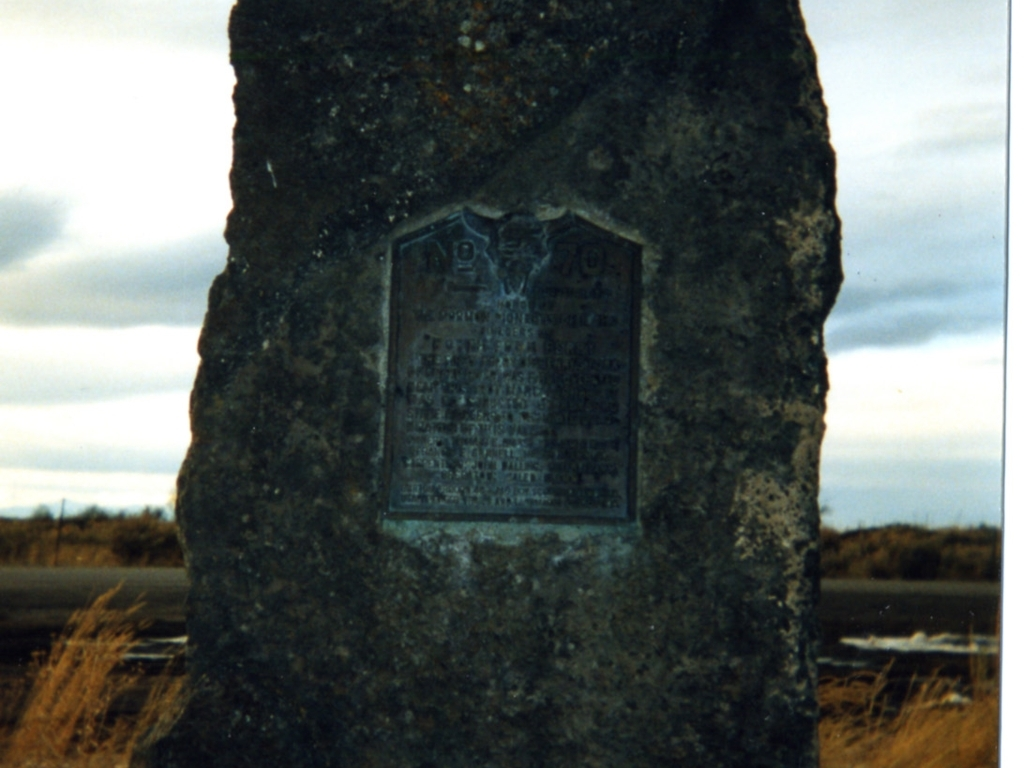What is the quality of this image?
A. Poor
B. Excellent
C. Average
Answer with the option's letter from the given choices directly. The quality of the image appears to be poor, which is option A from the given choices. The picture lacks sharpness and clarity making details hard to discern, especially regarding the text on the plaque. The lighting is flat, and the overall composition could be improved for better visual appeal. 